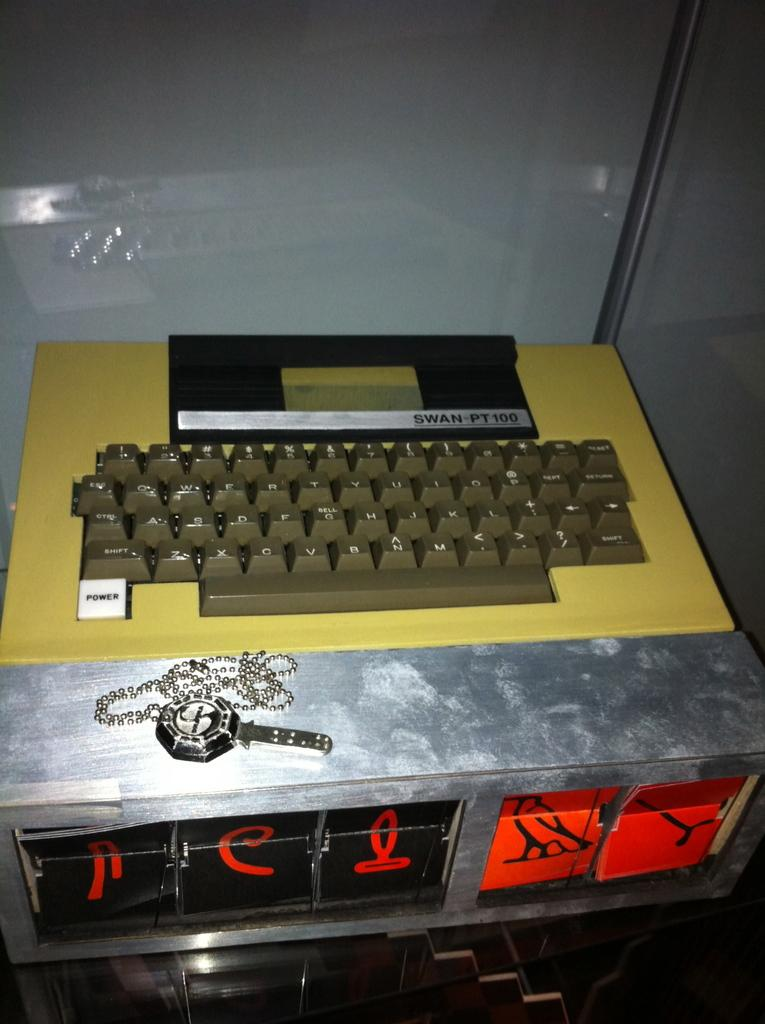<image>
Write a terse but informative summary of the picture. a keyboard in front of a sign that says swan -pt 100 